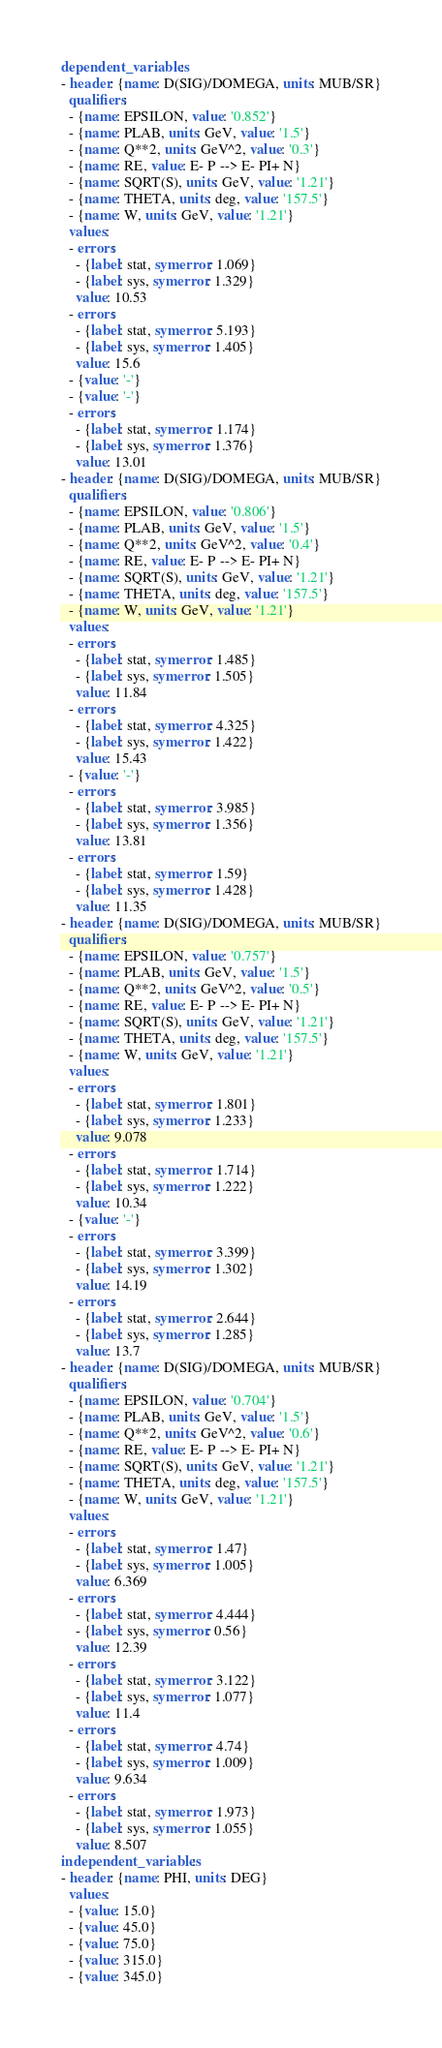<code> <loc_0><loc_0><loc_500><loc_500><_YAML_>dependent_variables:
- header: {name: D(SIG)/DOMEGA, units: MUB/SR}
  qualifiers:
  - {name: EPSILON, value: '0.852'}
  - {name: PLAB, units: GeV, value: '1.5'}
  - {name: Q**2, units: GeV^2, value: '0.3'}
  - {name: RE, value: E- P --> E- PI+ N}
  - {name: SQRT(S), units: GeV, value: '1.21'}
  - {name: THETA, units: deg, value: '157.5'}
  - {name: W, units: GeV, value: '1.21'}
  values:
  - errors:
    - {label: stat, symerror: 1.069}
    - {label: sys, symerror: 1.329}
    value: 10.53
  - errors:
    - {label: stat, symerror: 5.193}
    - {label: sys, symerror: 1.405}
    value: 15.6
  - {value: '-'}
  - {value: '-'}
  - errors:
    - {label: stat, symerror: 1.174}
    - {label: sys, symerror: 1.376}
    value: 13.01
- header: {name: D(SIG)/DOMEGA, units: MUB/SR}
  qualifiers:
  - {name: EPSILON, value: '0.806'}
  - {name: PLAB, units: GeV, value: '1.5'}
  - {name: Q**2, units: GeV^2, value: '0.4'}
  - {name: RE, value: E- P --> E- PI+ N}
  - {name: SQRT(S), units: GeV, value: '1.21'}
  - {name: THETA, units: deg, value: '157.5'}
  - {name: W, units: GeV, value: '1.21'}
  values:
  - errors:
    - {label: stat, symerror: 1.485}
    - {label: sys, symerror: 1.505}
    value: 11.84
  - errors:
    - {label: stat, symerror: 4.325}
    - {label: sys, symerror: 1.422}
    value: 15.43
  - {value: '-'}
  - errors:
    - {label: stat, symerror: 3.985}
    - {label: sys, symerror: 1.356}
    value: 13.81
  - errors:
    - {label: stat, symerror: 1.59}
    - {label: sys, symerror: 1.428}
    value: 11.35
- header: {name: D(SIG)/DOMEGA, units: MUB/SR}
  qualifiers:
  - {name: EPSILON, value: '0.757'}
  - {name: PLAB, units: GeV, value: '1.5'}
  - {name: Q**2, units: GeV^2, value: '0.5'}
  - {name: RE, value: E- P --> E- PI+ N}
  - {name: SQRT(S), units: GeV, value: '1.21'}
  - {name: THETA, units: deg, value: '157.5'}
  - {name: W, units: GeV, value: '1.21'}
  values:
  - errors:
    - {label: stat, symerror: 1.801}
    - {label: sys, symerror: 1.233}
    value: 9.078
  - errors:
    - {label: stat, symerror: 1.714}
    - {label: sys, symerror: 1.222}
    value: 10.34
  - {value: '-'}
  - errors:
    - {label: stat, symerror: 3.399}
    - {label: sys, symerror: 1.302}
    value: 14.19
  - errors:
    - {label: stat, symerror: 2.644}
    - {label: sys, symerror: 1.285}
    value: 13.7
- header: {name: D(SIG)/DOMEGA, units: MUB/SR}
  qualifiers:
  - {name: EPSILON, value: '0.704'}
  - {name: PLAB, units: GeV, value: '1.5'}
  - {name: Q**2, units: GeV^2, value: '0.6'}
  - {name: RE, value: E- P --> E- PI+ N}
  - {name: SQRT(S), units: GeV, value: '1.21'}
  - {name: THETA, units: deg, value: '157.5'}
  - {name: W, units: GeV, value: '1.21'}
  values:
  - errors:
    - {label: stat, symerror: 1.47}
    - {label: sys, symerror: 1.005}
    value: 6.369
  - errors:
    - {label: stat, symerror: 4.444}
    - {label: sys, symerror: 0.56}
    value: 12.39
  - errors:
    - {label: stat, symerror: 3.122}
    - {label: sys, symerror: 1.077}
    value: 11.4
  - errors:
    - {label: stat, symerror: 4.74}
    - {label: sys, symerror: 1.009}
    value: 9.634
  - errors:
    - {label: stat, symerror: 1.973}
    - {label: sys, symerror: 1.055}
    value: 8.507
independent_variables:
- header: {name: PHI, units: DEG}
  values:
  - {value: 15.0}
  - {value: 45.0}
  - {value: 75.0}
  - {value: 315.0}
  - {value: 345.0}
</code> 